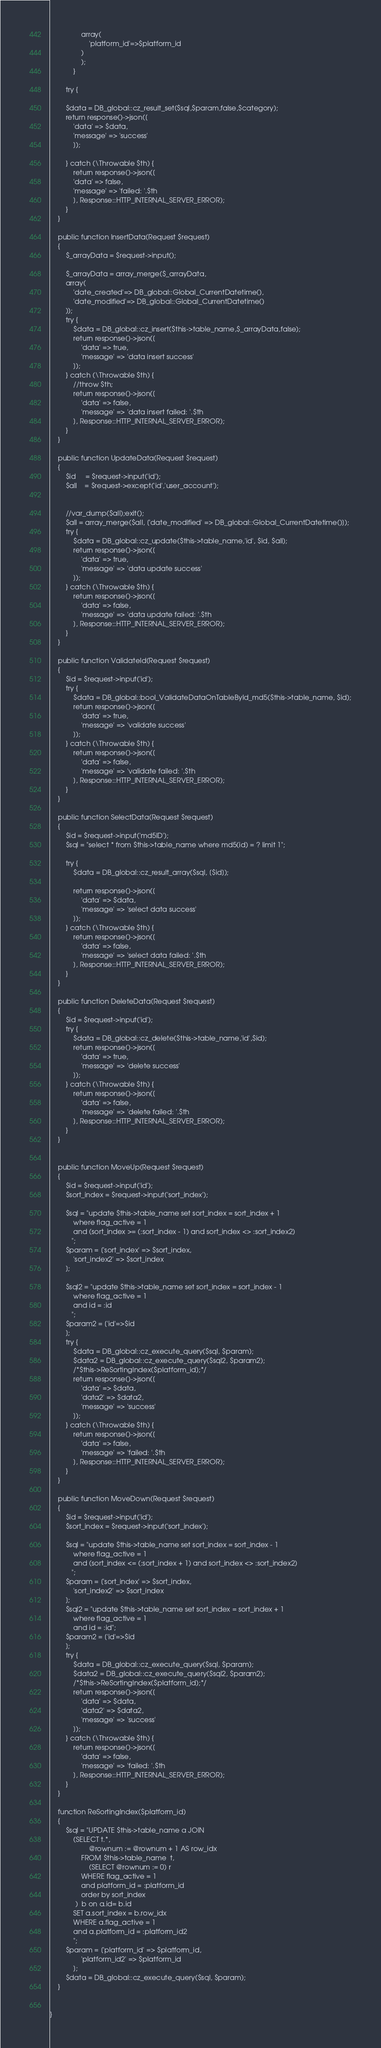<code> <loc_0><loc_0><loc_500><loc_500><_PHP_>                array(
                    'platform_id'=>$platform_id
                )
                );
            }    

        try {

        $data = DB_global::cz_result_set($sql,$param,false,$category);
        return response()->json([
            'data' => $data,
            'message' => 'success'
            ]);

        } catch (\Throwable $th) {
            return response()->json([
            'data' => false,
            'message' => 'failed: '.$th
            ], Response::HTTP_INTERNAL_SERVER_ERROR);
        }
    }

    public function InsertData(Request $request)
    {
        $_arrayData = $request->input();

        $_arrayData = array_merge($_arrayData,
        array(
            'date_created'=> DB_global::Global_CurrentDatetime(),
            'date_modified'=> DB_global::Global_CurrentDatetime()
        ));
        try {
            $data = DB_global::cz_insert($this->table_name,$_arrayData,false);
            return response()->json([
                'data' => true,
                'message' => 'data insert success'
            ]);
        } catch (\Throwable $th) {
            //throw $th;
            return response()->json([
                'data' => false,
                'message' => 'data insert failed: '.$th
            ], Response::HTTP_INTERNAL_SERVER_ERROR);
        }
    }

    public function UpdateData(Request $request)
    {
        $id     = $request->input('id');        
        $all    = $request->except('id','user_account');


        //var_dump($all);exit();
        $all = array_merge($all, ['date_modified' => DB_global::Global_CurrentDatetime()]);
        try {
            $data = DB_global::cz_update($this->table_name,'id', $id, $all);
            return response()->json([
                'data' => true,
                'message' => 'data update success'
            ]);
        } catch (\Throwable $th) {
            return response()->json([
                'data' => false,
                'message' => 'data update failed: '.$th
            ], Response::HTTP_INTERNAL_SERVER_ERROR);
        }
    }

    public function ValidateId(Request $request)
    {
        $id = $request->input('id');
        try {
            $data = DB_global::bool_ValidateDataOnTableById_md5($this->table_name, $id);
            return response()->json([
                'data' => true,
                'message' => 'validate success'
            ]);
        } catch (\Throwable $th) {
            return response()->json([
                'data' => false,
                'message' => 'validate failed: '.$th
            ], Response::HTTP_INTERNAL_SERVER_ERROR);
        }
    }

    public function SelectData(Request $request)
	{
        $id = $request->input('md5ID');
		$sql = "select * from $this->table_name where md5(id) = ? limit 1";
        
        try {
            $data = DB_global::cz_result_array($sql, [$id]);

            return response()->json([
                'data' => $data,
                'message' => 'select data success'
            ]);
        } catch (\Throwable $th) {
            return response()->json([
                'data' => false,
                'message' => 'select data failed: '.$th
            ], Response::HTTP_INTERNAL_SERVER_ERROR);
        }
    }

    public function DeleteData(Request $request)
    {
        $id = $request->input('id');
        try {
            $data = DB_global::cz_delete($this->table_name,'id',$id);
            return response()->json([
                'data' => true,
                'message' => 'delete success'
            ]);
        } catch (\Throwable $th) {
            return response()->json([
                'data' => false,
                'message' => 'delete failed: '.$th
            ], Response::HTTP_INTERNAL_SERVER_ERROR);
        }
    }


    public function MoveUp(Request $request)
	{
        $id = $request->input('id');
        $sort_index = $request->input('sort_index');

        $sql = "update $this->table_name set sort_index = sort_index + 1
            where flag_active = 1
            and (sort_index >= (:sort_index - 1) and sort_index <> :sort_index2)
           ";
        $param = ['sort_index' => $sort_index,
            'sort_index2' => $sort_index
        ];

        $sql2 = "update $this->table_name set sort_index = sort_index - 1
            where flag_active = 1
            and id = :id
           ";
        $param2 = ['id'=>$id
        ];
        try {
            $data = DB_global::cz_execute_query($sql, $param);
            $data2 = DB_global::cz_execute_query($sql2, $param2);
            /*$this->ReSortingIndex($platform_id);*/
            return response()->json([
                'data' => $data,
                'data2' => $data2,
                'message' => 'success'
            ]);
        } catch (\Throwable $th) {
            return response()->json([
                'data' => false,
                'message' => 'failed: '.$th
            ], Response::HTTP_INTERNAL_SERVER_ERROR);
        }
	}

	public function MoveDown(Request $request)
	{
        $id = $request->input('id');
        $sort_index = $request->input('sort_index');

        $sql = "update $this->table_name set sort_index = sort_index - 1
            where flag_active = 1
            and (sort_index <= (:sort_index + 1) and sort_index <> :sort_index2)
           ";
        $param = ['sort_index' => $sort_index,
            'sort_index2' => $sort_index
        ];
        $sql2 = "update $this->table_name set sort_index = sort_index + 1
            where flag_active = 1
            and id = :id";
        $param2 = ['id'=>$id
        ];
        try {
            $data = DB_global::cz_execute_query($sql, $param);
            $data2 = DB_global::cz_execute_query($sql2, $param2);
            /*$this->ReSortingIndex($platform_id);*/
            return response()->json([
                'data' => $data,
                'data2' => $data2,
                'message' => 'success'
            ]);
        } catch (\Throwable $th) {
            return response()->json([
                'data' => false,
                'message' => 'failed: '.$th
            ], Response::HTTP_INTERNAL_SERVER_ERROR);
        }
	}

	function ReSortingIndex($platform_id)
	{
		$sql = "UPDATE $this->table_name a JOIN
			(SELECT t.*,
			        @rownum := @rownum + 1 AS row_idx
			    FROM $this->table_name  t,
			        (SELECT @rownum := 0) r
                WHERE flag_active = 1
                and platform_id = :platform_id
				order by sort_index
			 )  b on a.id= b.id
			SET a.sort_index = b.row_idx
            WHERE a.flag_active = 1
            and a.platform_id = :platform_id2
            ";
        $param = ['platform_id' => $platform_id,
                'platform_id2' => $platform_id
            ];
        $data = DB_global::cz_execute_query($sql, $param);
	}


}
</code> 